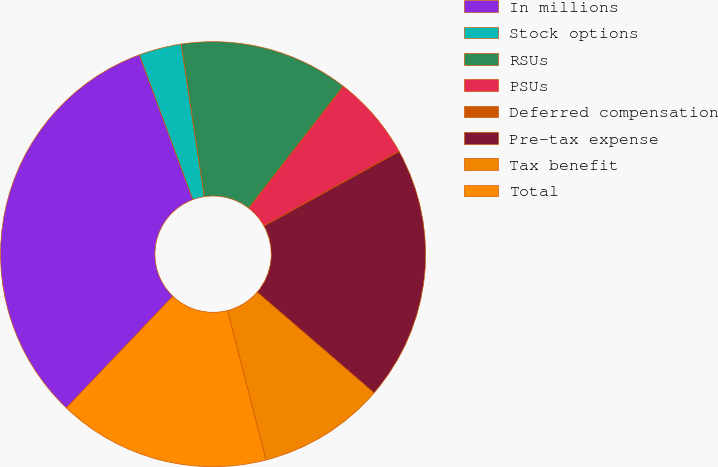<chart> <loc_0><loc_0><loc_500><loc_500><pie_chart><fcel>In millions<fcel>Stock options<fcel>RSUs<fcel>PSUs<fcel>Deferred compensation<fcel>Pre-tax expense<fcel>Tax benefit<fcel>Total<nl><fcel>32.24%<fcel>3.24%<fcel>12.9%<fcel>6.46%<fcel>0.01%<fcel>19.35%<fcel>9.68%<fcel>16.13%<nl></chart> 